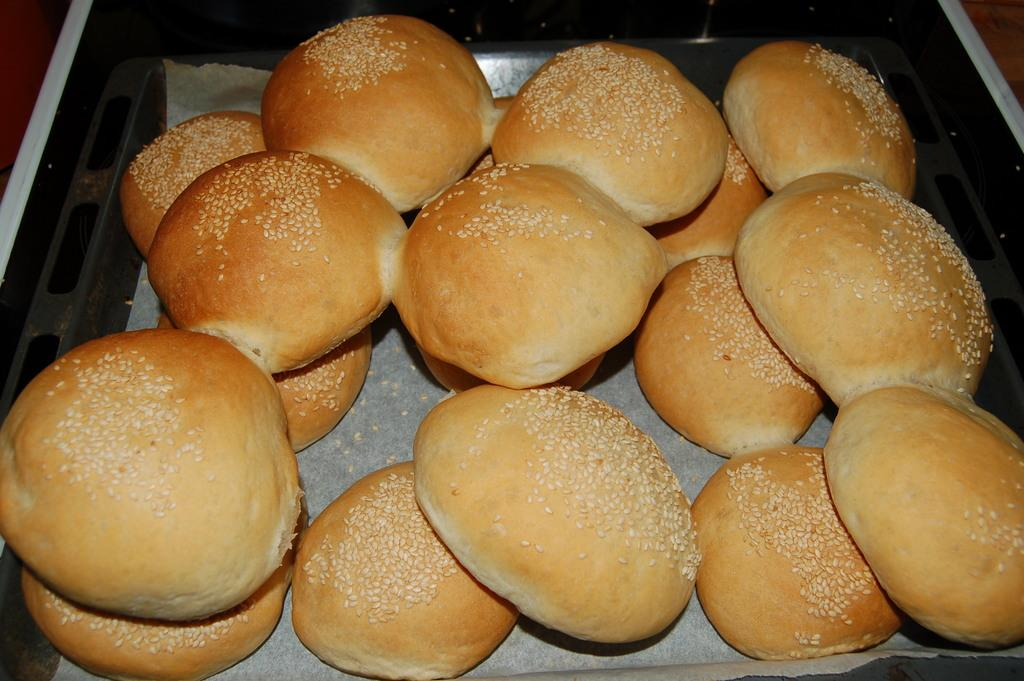What type of food can be seen in the image? There are buns in the image. What else is present in the image besides the buns? There is paper in the image. How are the buns and paper arranged in the image? The buns and paper are in a container. What direction is the cactus facing in the image? There is no cactus present in the image. 